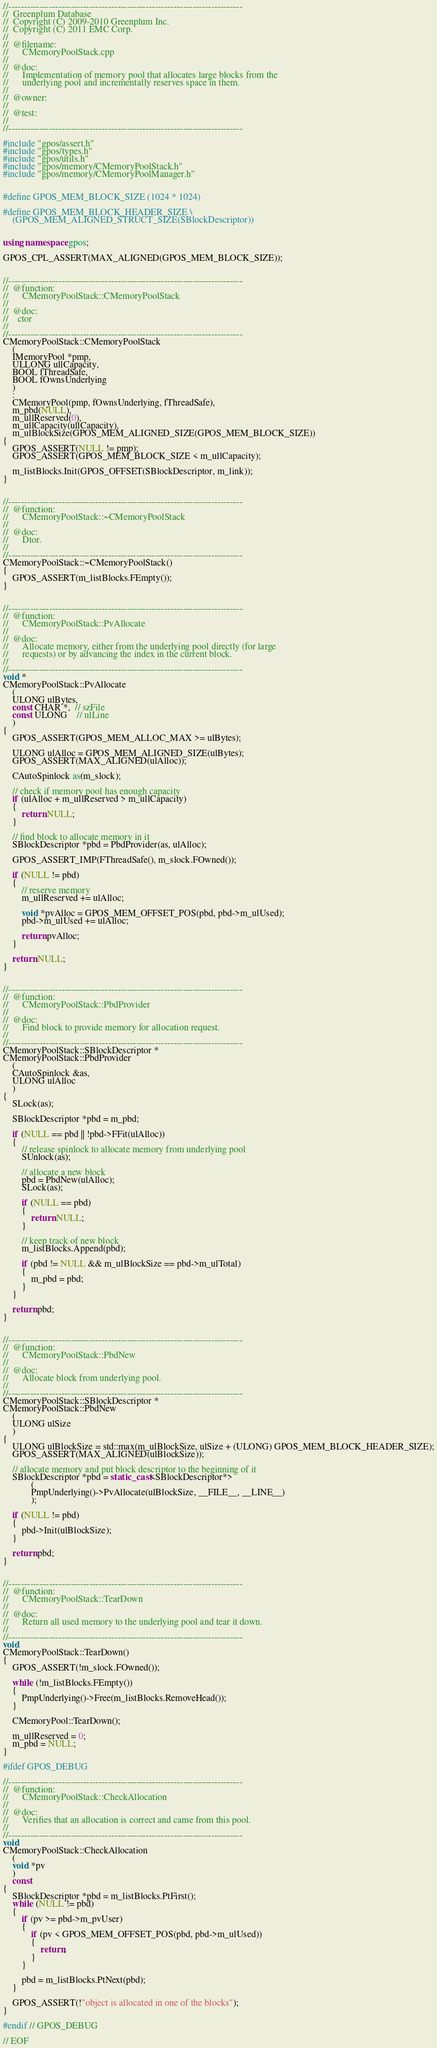<code> <loc_0><loc_0><loc_500><loc_500><_C++_>//---------------------------------------------------------------------------
//	Greenplum Database
//	Copyright (C) 2009-2010 Greenplum Inc.
//	Copyright (C) 2011 EMC Corp.
//
//	@filename:
//		CMemoryPoolStack.cpp
//
//	@doc:
//		Implementation of memory pool that allocates large blocks from the
//		underlying pool and incrementally reserves space in them.
//
//	@owner:
//
//	@test:
//
//---------------------------------------------------------------------------

#include "gpos/assert.h"
#include "gpos/types.h"
#include "gpos/utils.h"
#include "gpos/memory/CMemoryPoolStack.h"
#include "gpos/memory/CMemoryPoolManager.h"


#define GPOS_MEM_BLOCK_SIZE (1024 * 1024)

#define GPOS_MEM_BLOCK_HEADER_SIZE \
	(GPOS_MEM_ALIGNED_STRUCT_SIZE(SBlockDescriptor))


using namespace gpos;

GPOS_CPL_ASSERT(MAX_ALIGNED(GPOS_MEM_BLOCK_SIZE));


//---------------------------------------------------------------------------
//	@function:
//		CMemoryPoolStack::CMemoryPoolStack
//
//	@doc:
//	  ctor
//
//---------------------------------------------------------------------------
CMemoryPoolStack::CMemoryPoolStack
	(
	IMemoryPool *pmp,
	ULLONG ullCapacity,
	BOOL fThreadSafe,
	BOOL fOwnsUnderlying
	)
	:
	CMemoryPool(pmp, fOwnsUnderlying, fThreadSafe),
	m_pbd(NULL),
	m_ullReserved(0),
	m_ullCapacity(ullCapacity),
	m_ulBlockSize(GPOS_MEM_ALIGNED_SIZE(GPOS_MEM_BLOCK_SIZE))
{
	GPOS_ASSERT(NULL != pmp);
	GPOS_ASSERT(GPOS_MEM_BLOCK_SIZE < m_ullCapacity);

	m_listBlocks.Init(GPOS_OFFSET(SBlockDescriptor, m_link));
}


//---------------------------------------------------------------------------
//	@function:
//		CMemoryPoolStack::~CMemoryPoolStack
//
//	@doc:
//		Dtor.
//
//---------------------------------------------------------------------------
CMemoryPoolStack::~CMemoryPoolStack()
{
	GPOS_ASSERT(m_listBlocks.FEmpty());
}


//---------------------------------------------------------------------------
//	@function:
//		CMemoryPoolStack::PvAllocate
//
//	@doc:
//		Allocate memory, either from the underlying pool directly (for large
//		requests) or by advancing the index in the current block.
//
//---------------------------------------------------------------------------
void *
CMemoryPoolStack::PvAllocate
	(
	ULONG ulBytes,
	const CHAR *,  // szFile
	const ULONG    // ulLine
	)
{
	GPOS_ASSERT(GPOS_MEM_ALLOC_MAX >= ulBytes);

	ULONG ulAlloc = GPOS_MEM_ALIGNED_SIZE(ulBytes);
	GPOS_ASSERT(MAX_ALIGNED(ulAlloc));

	CAutoSpinlock as(m_slock);

	// check if memory pool has enough capacity
	if (ulAlloc + m_ullReserved > m_ullCapacity)
	{
		return NULL;
	}

	// find block to allocate memory in it
	SBlockDescriptor *pbd = PbdProvider(as, ulAlloc);

	GPOS_ASSERT_IMP(FThreadSafe(), m_slock.FOwned());

	if (NULL != pbd)
	{
		// reserve memory
		m_ullReserved += ulAlloc;

		void *pvAlloc = GPOS_MEM_OFFSET_POS(pbd, pbd->m_ulUsed);
		pbd->m_ulUsed += ulAlloc;

		return pvAlloc;
	}

	return NULL;
}


//---------------------------------------------------------------------------
//	@function:
//		CMemoryPoolStack::PbdProvider
//
//	@doc:
//		Find block to provide memory for allocation request.
//
//---------------------------------------------------------------------------
CMemoryPoolStack::SBlockDescriptor *
CMemoryPoolStack::PbdProvider
	(
	CAutoSpinlock &as,
	ULONG ulAlloc
	)
{
	SLock(as);

	SBlockDescriptor *pbd = m_pbd;

	if (NULL == pbd || !pbd->FFit(ulAlloc))
	{
		// release spinlock to allocate memory from underlying pool
		SUnlock(as);

		// allocate a new block
		pbd = PbdNew(ulAlloc);
		SLock(as);

		if (NULL == pbd)
		{
			return NULL;
		}

		// keep track of new block
		m_listBlocks.Append(pbd);

		if (pbd != NULL && m_ulBlockSize == pbd->m_ulTotal)
		{
			m_pbd = pbd;
		}
	}

	return pbd;
}


//---------------------------------------------------------------------------
//	@function:
//		CMemoryPoolStack::PbdNew
//
//	@doc:
//		Allocate block from underlying pool.
//
//---------------------------------------------------------------------------
CMemoryPoolStack::SBlockDescriptor *
CMemoryPoolStack::PbdNew
	(
	ULONG ulSize
	)
{
	ULONG ulBlockSize = std::max(m_ulBlockSize, ulSize + (ULONG) GPOS_MEM_BLOCK_HEADER_SIZE);
	GPOS_ASSERT(MAX_ALIGNED(ulBlockSize));

	// allocate memory and put block descriptor to the beginning of it
	SBlockDescriptor *pbd = static_cast<SBlockDescriptor*>
			(
			PmpUnderlying()->PvAllocate(ulBlockSize, __FILE__, __LINE__)
			);

	if (NULL != pbd)
	{
		pbd->Init(ulBlockSize);
	}

	return pbd;
}


//---------------------------------------------------------------------------
//	@function:
//		CMemoryPoolStack::TearDown
//
//	@doc:
//		Return all used memory to the underlying pool and tear it down.
//
//---------------------------------------------------------------------------
void
CMemoryPoolStack::TearDown()
{
	GPOS_ASSERT(!m_slock.FOwned());

	while (!m_listBlocks.FEmpty())
	{
		PmpUnderlying()->Free(m_listBlocks.RemoveHead());
	}

	CMemoryPool::TearDown();

	m_ullReserved = 0;
	m_pbd = NULL;
}

#ifdef GPOS_DEBUG

//---------------------------------------------------------------------------
//	@function:
//		CMemoryPoolStack::CheckAllocation
//
//	@doc:
//		Verifies that an allocation is correct and came from this pool.
//
//---------------------------------------------------------------------------
void
CMemoryPoolStack::CheckAllocation
	(
	void *pv
	)
	const
{
	SBlockDescriptor *pbd = m_listBlocks.PtFirst();
	while (NULL != pbd)
	{
		if (pv >= pbd->m_pvUser)
		{
			if (pv < GPOS_MEM_OFFSET_POS(pbd, pbd->m_ulUsed))
			{
				return;
			}
		}

		pbd = m_listBlocks.PtNext(pbd);
	}

	GPOS_ASSERT(!"object is allocated in one of the blocks");
}

#endif // GPOS_DEBUG

// EOF

</code> 